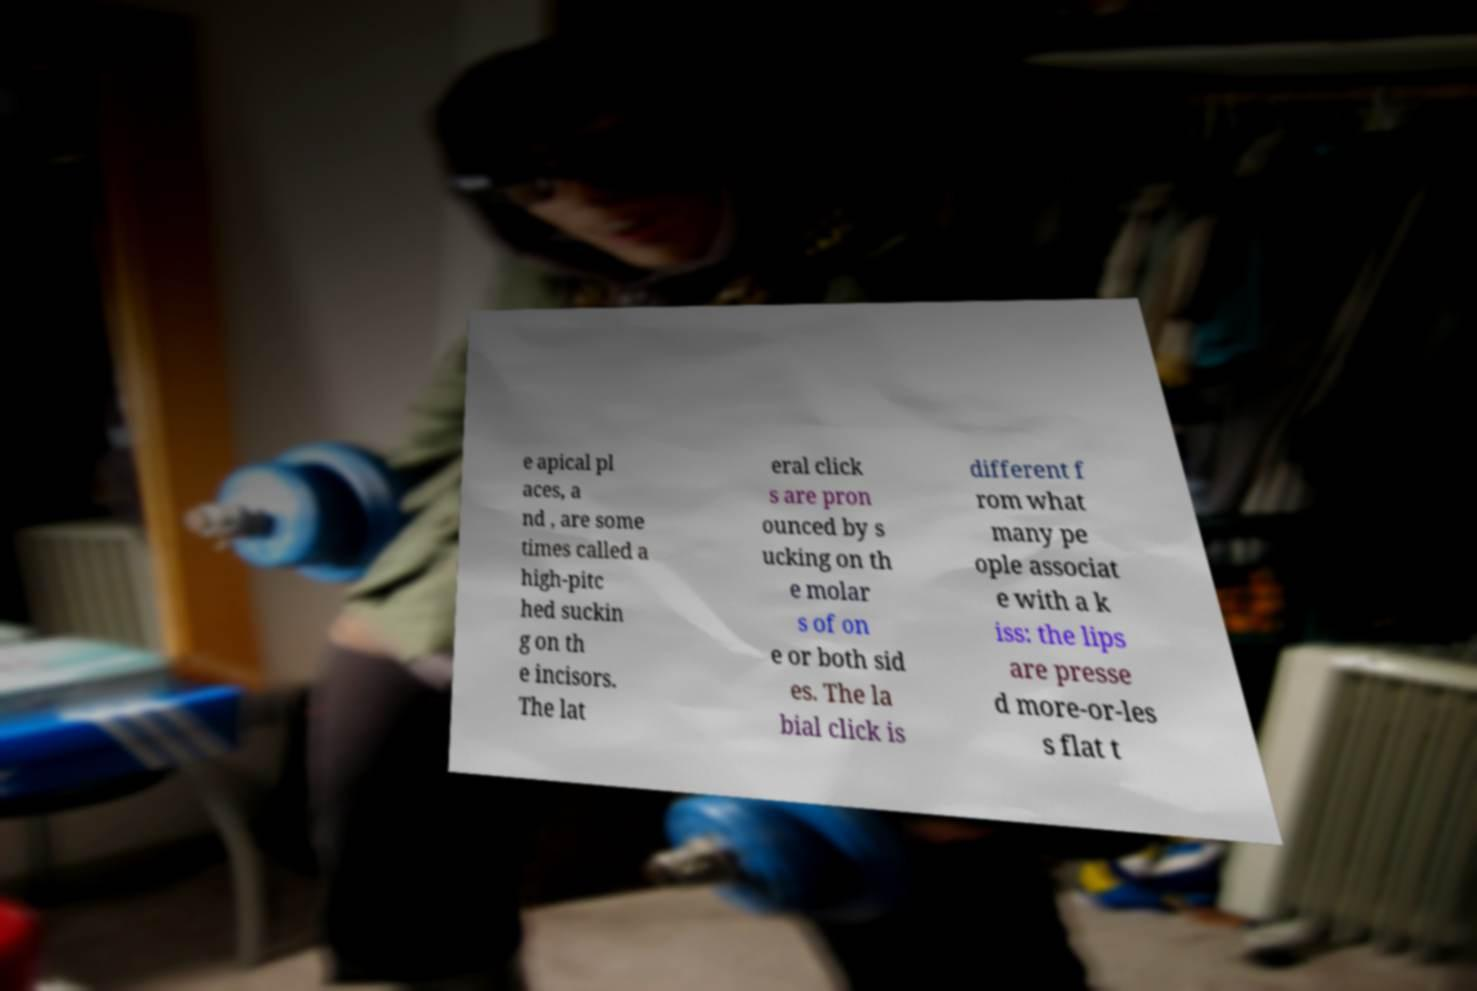Can you read and provide the text displayed in the image?This photo seems to have some interesting text. Can you extract and type it out for me? e apical pl aces, a nd , are some times called a high-pitc hed suckin g on th e incisors. The lat eral click s are pron ounced by s ucking on th e molar s of on e or both sid es. The la bial click is different f rom what many pe ople associat e with a k iss: the lips are presse d more-or-les s flat t 